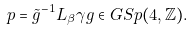<formula> <loc_0><loc_0><loc_500><loc_500>p = \tilde { g } ^ { - 1 } L _ { \beta } \gamma g \in G S p ( 4 , \mathbb { Z } ) .</formula> 